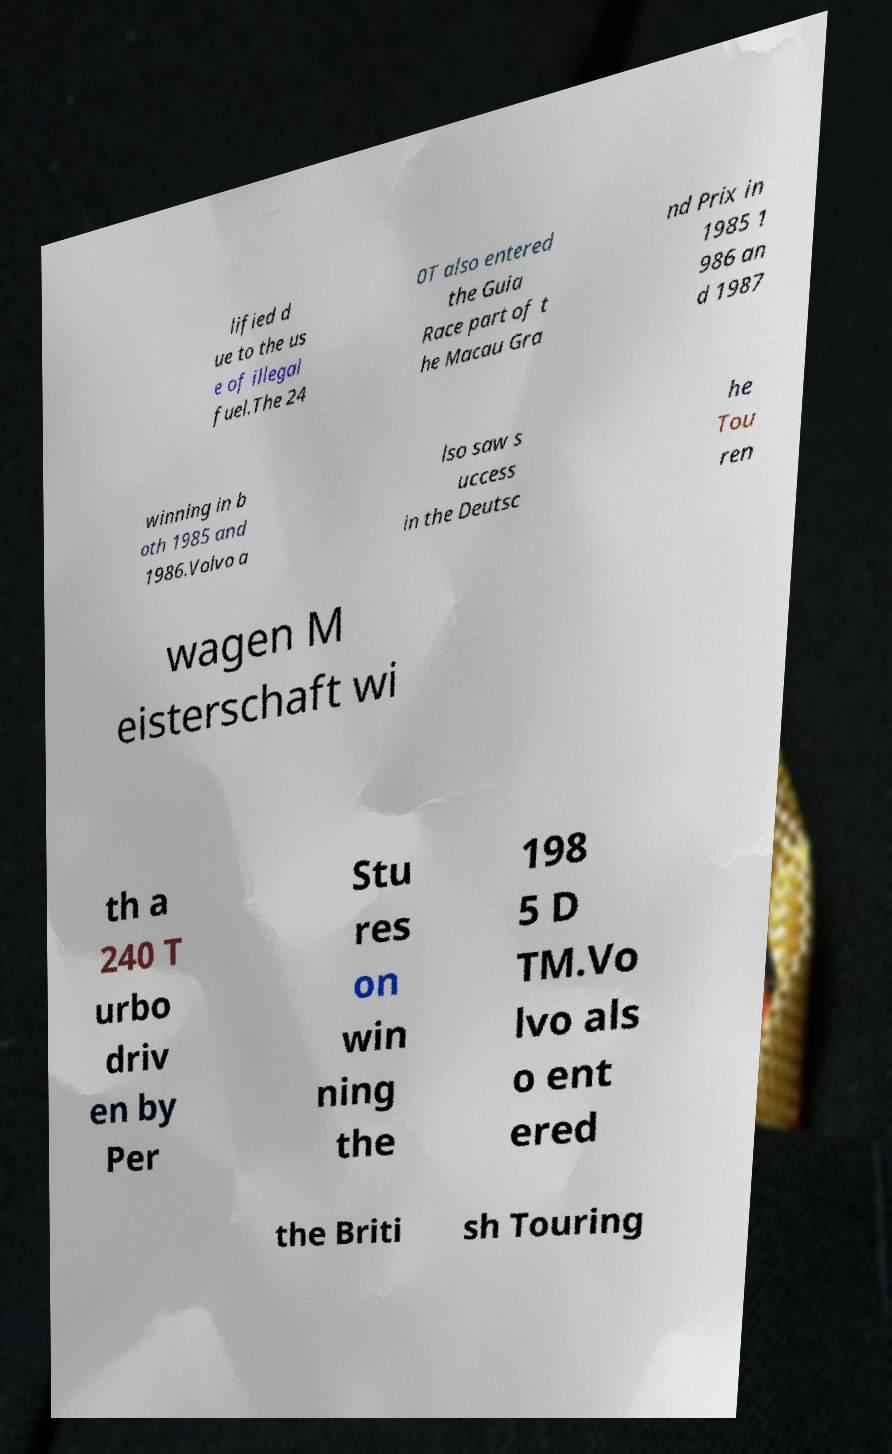Can you accurately transcribe the text from the provided image for me? lified d ue to the us e of illegal fuel.The 24 0T also entered the Guia Race part of t he Macau Gra nd Prix in 1985 1 986 an d 1987 winning in b oth 1985 and 1986.Volvo a lso saw s uccess in the Deutsc he Tou ren wagen M eisterschaft wi th a 240 T urbo driv en by Per Stu res on win ning the 198 5 D TM.Vo lvo als o ent ered the Briti sh Touring 